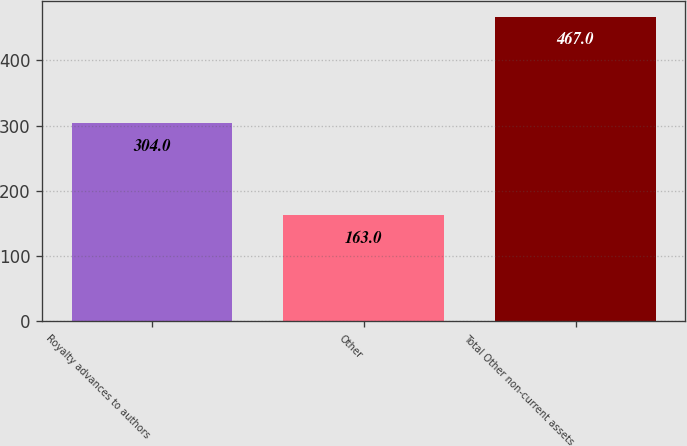<chart> <loc_0><loc_0><loc_500><loc_500><bar_chart><fcel>Royalty advances to authors<fcel>Other<fcel>Total Other non-current assets<nl><fcel>304<fcel>163<fcel>467<nl></chart> 